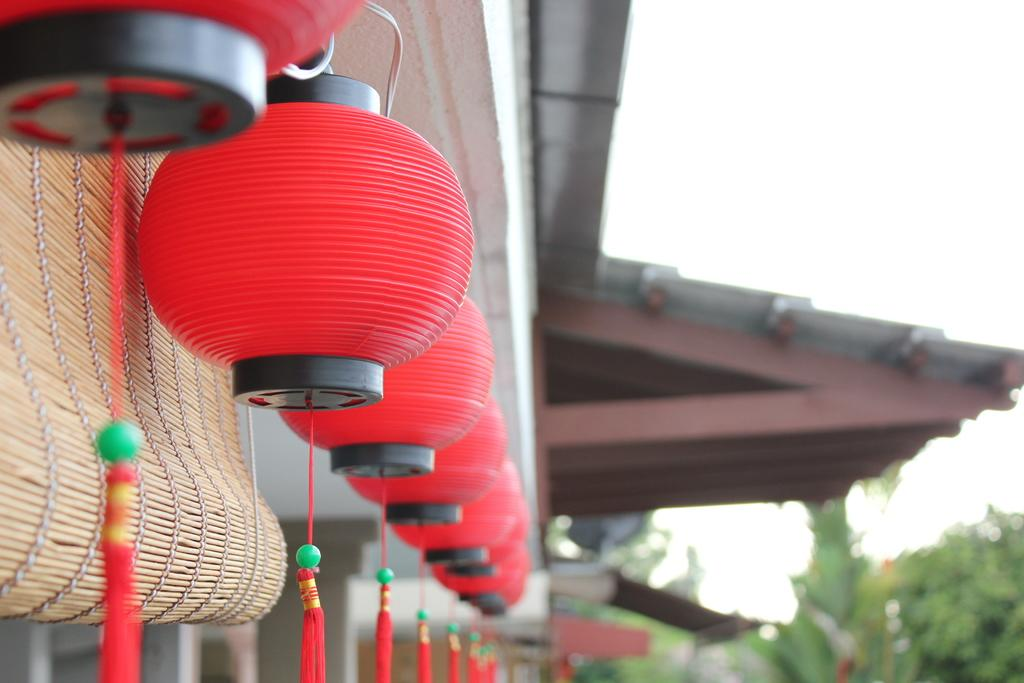What type of lighting is present in the image? There are lanterns in the image. What color are the lanterns? The lanterns are red in color. What is located on the left side of the image? There is a blind on the left side of the image. What can be seen in the background of the image? There is a building, trees, and the sky visible in the background of the image. Are there any fairies flying around the lanterns in the image? There are no fairies present in the image; it only features lanterns, a blind, and the background elements. What type of tool is being used to fix the building in the image? There is no tool or repair work being depicted in the image; it only shows lanterns, a blind, and the background elements. 